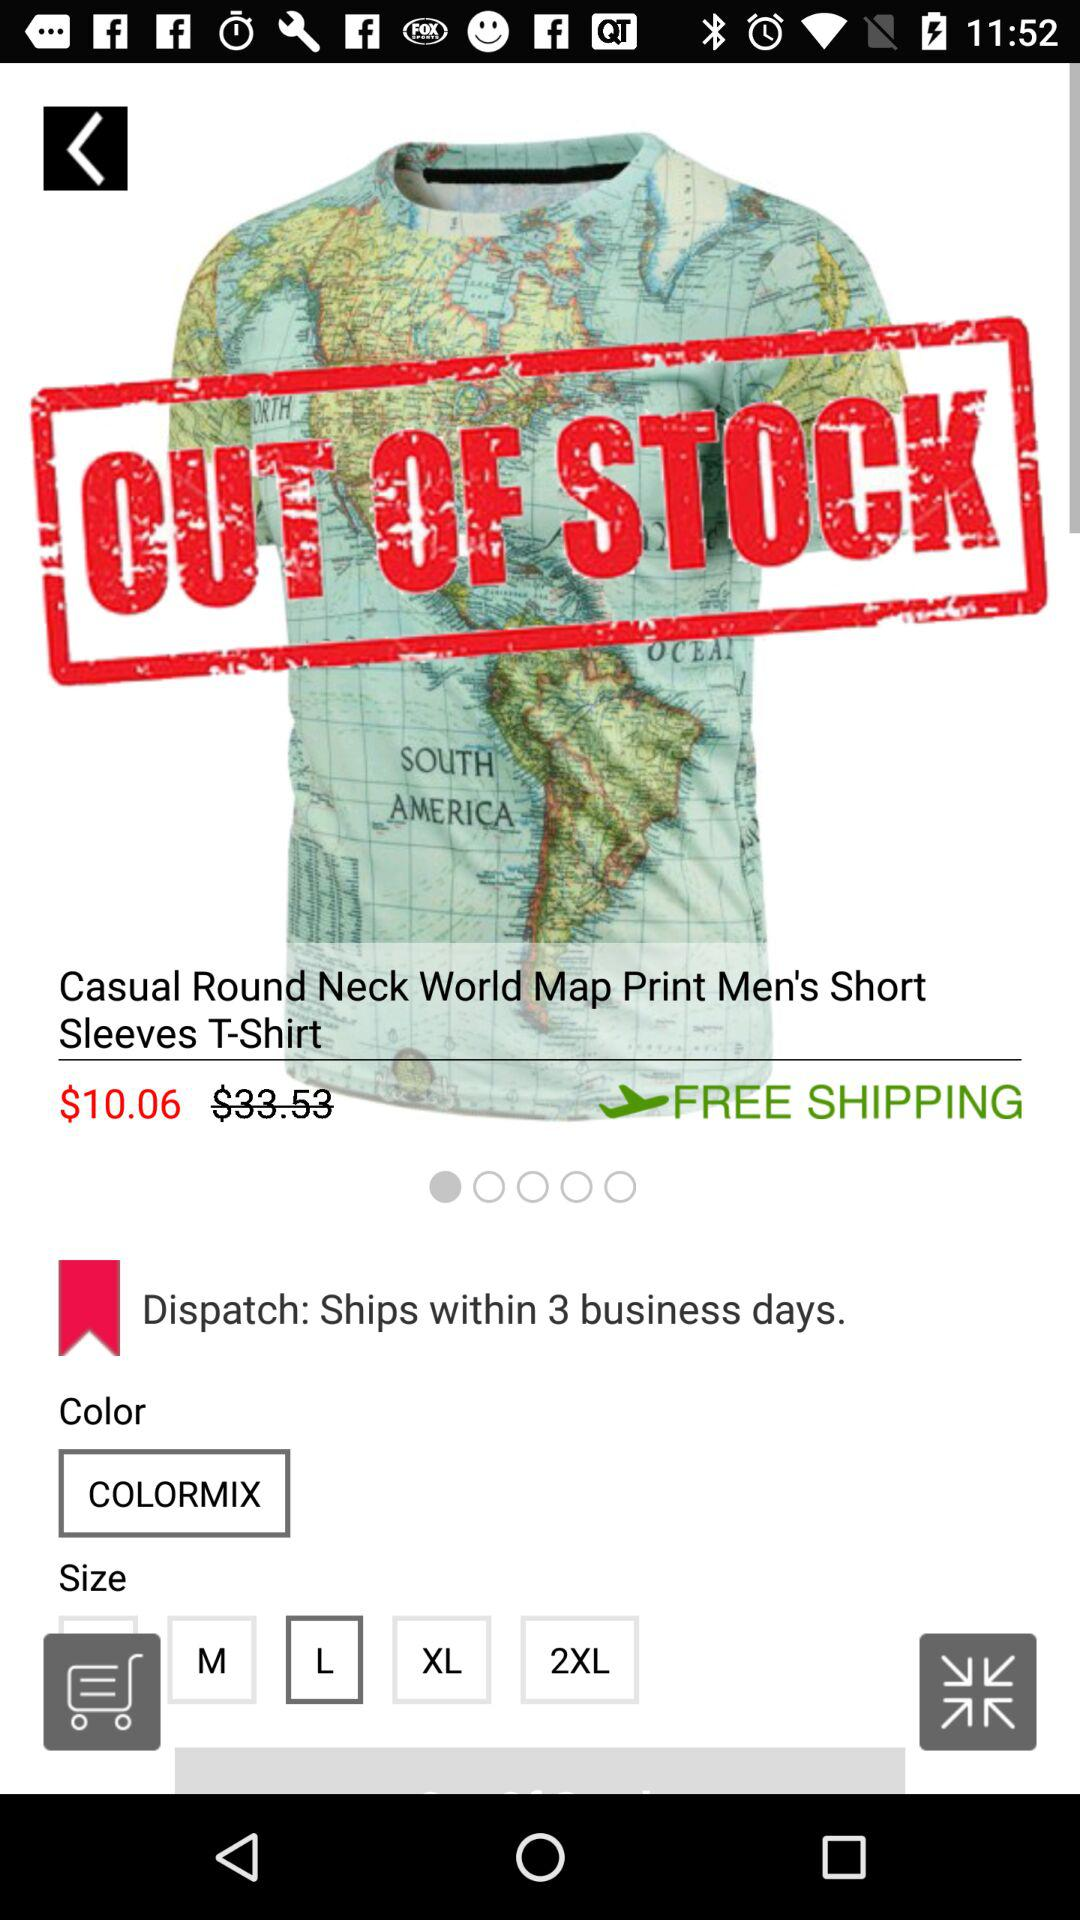How many sizes are available for this shirt?
Answer the question using a single word or phrase. 5 